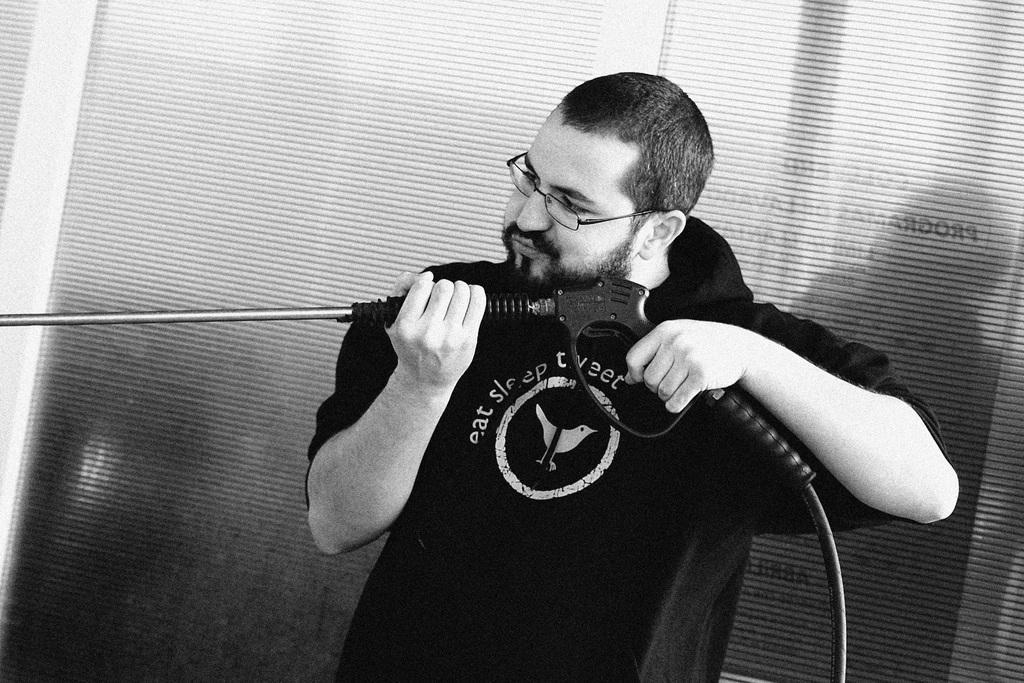Please provide a concise description of this image. In this image we can see a man standing and holding an object. In the background there are blinds. 